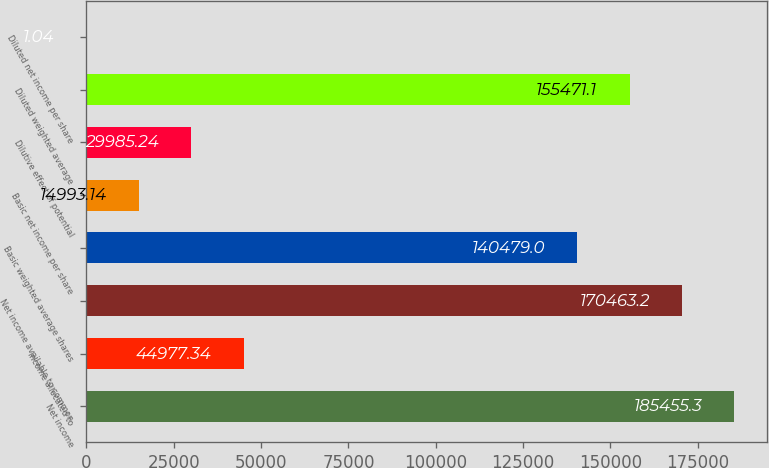Convert chart to OTSL. <chart><loc_0><loc_0><loc_500><loc_500><bar_chart><fcel>Net income<fcel>Income allocated to<fcel>Net income available to common<fcel>Basic weighted average shares<fcel>Basic net income per share<fcel>Dilutive effect of potential<fcel>Diluted weighted average<fcel>Diluted net income per share<nl><fcel>185455<fcel>44977.3<fcel>170463<fcel>140479<fcel>14993.1<fcel>29985.2<fcel>155471<fcel>1.04<nl></chart> 